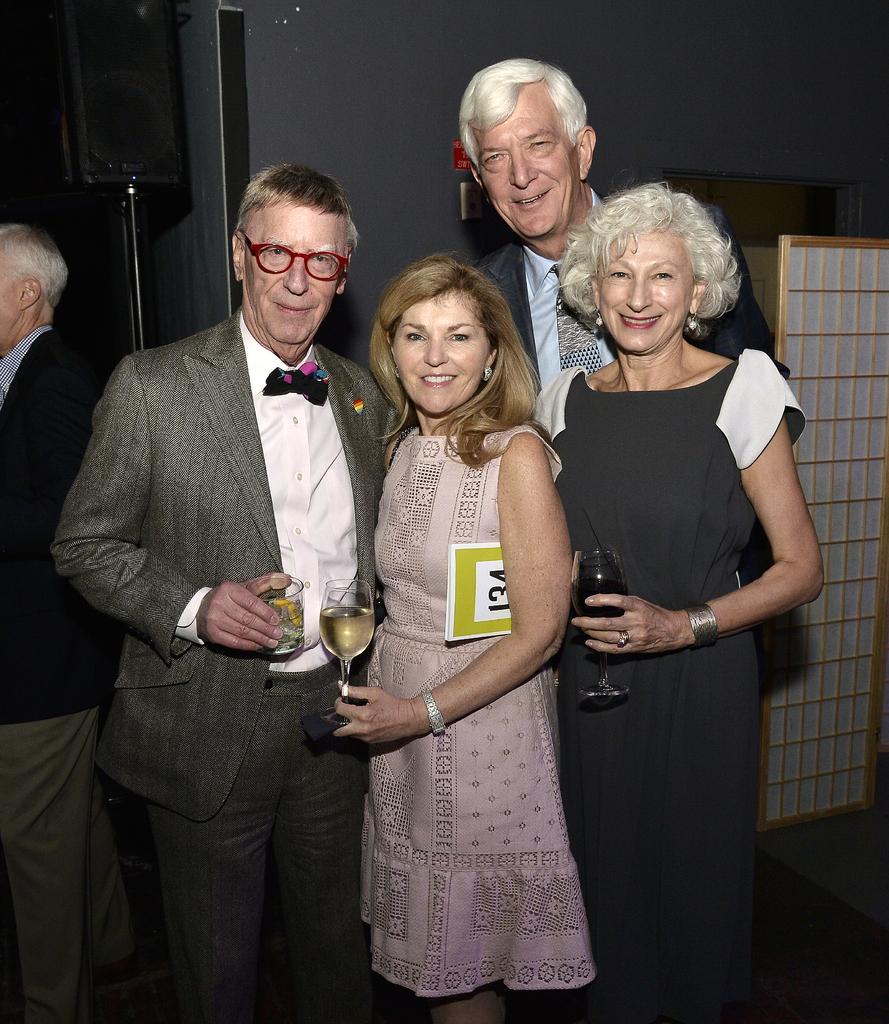Can you describe this image briefly? There are four people standing. In the left a person is holding glass and wearing a specs. And the lady in the center is holding a wine glass and a book. In the background there is a wall. 